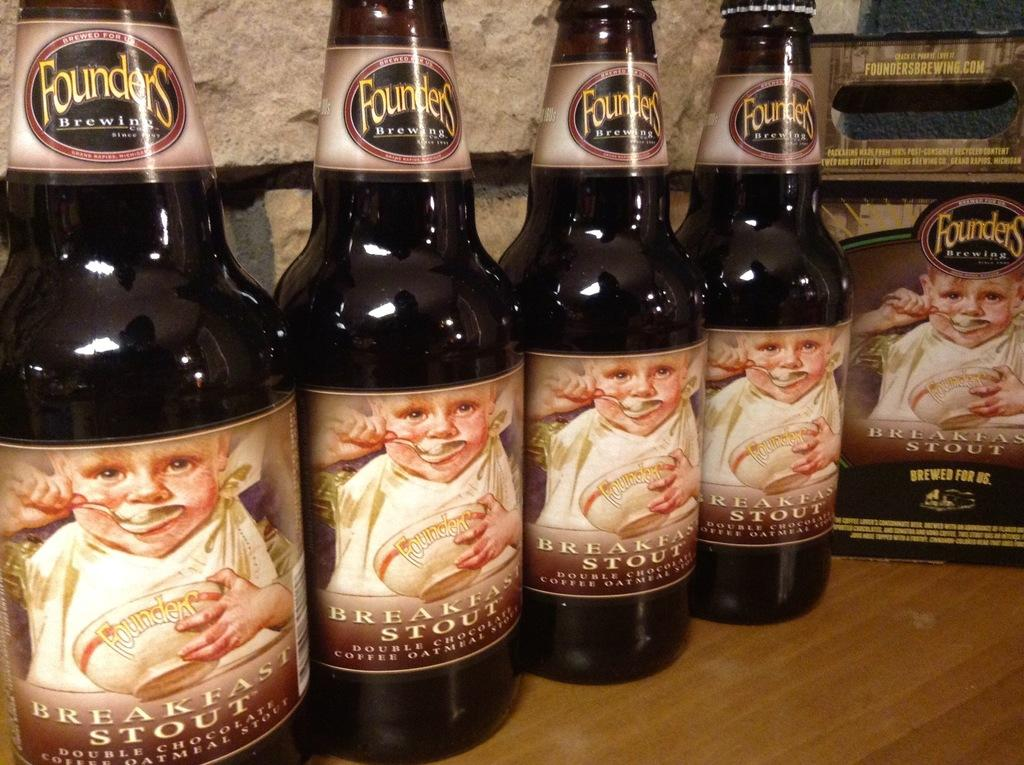<image>
Describe the image concisely. four bottles of founders breakfast stout standing next to each other 